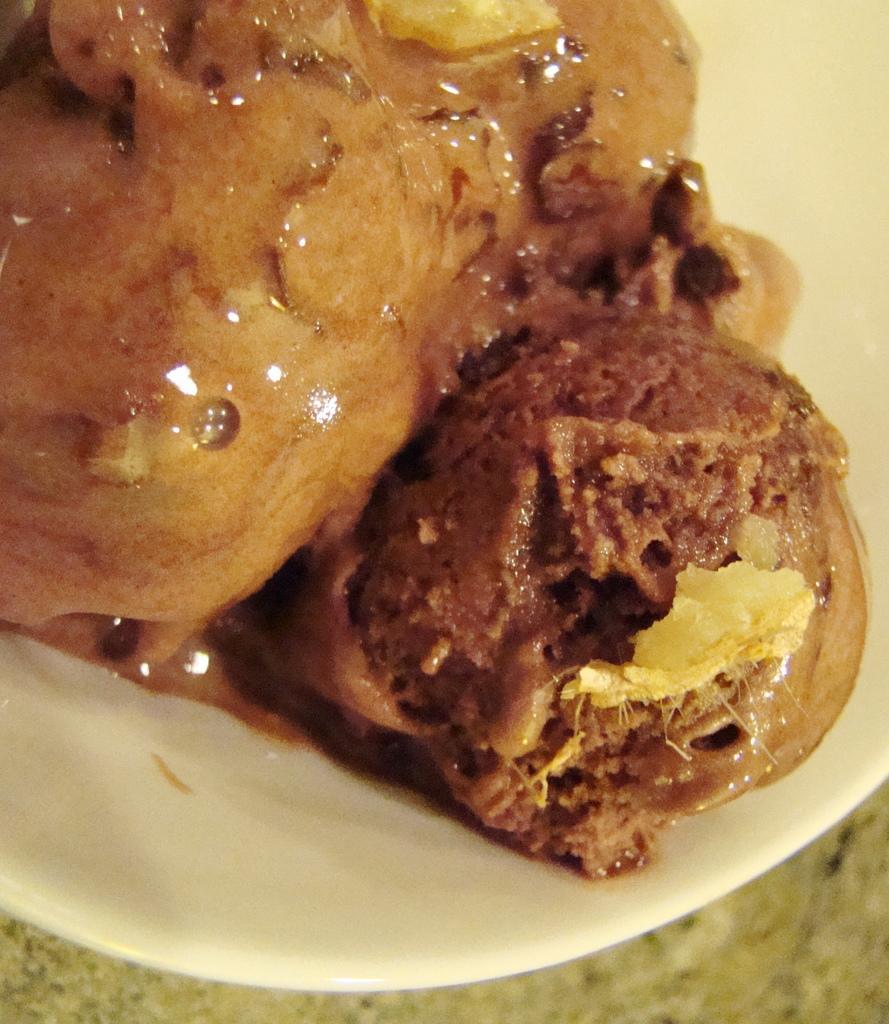In one or two sentences, can you explain what this image depicts? In this picture we can see food in the plate and this plate is on the platform. 